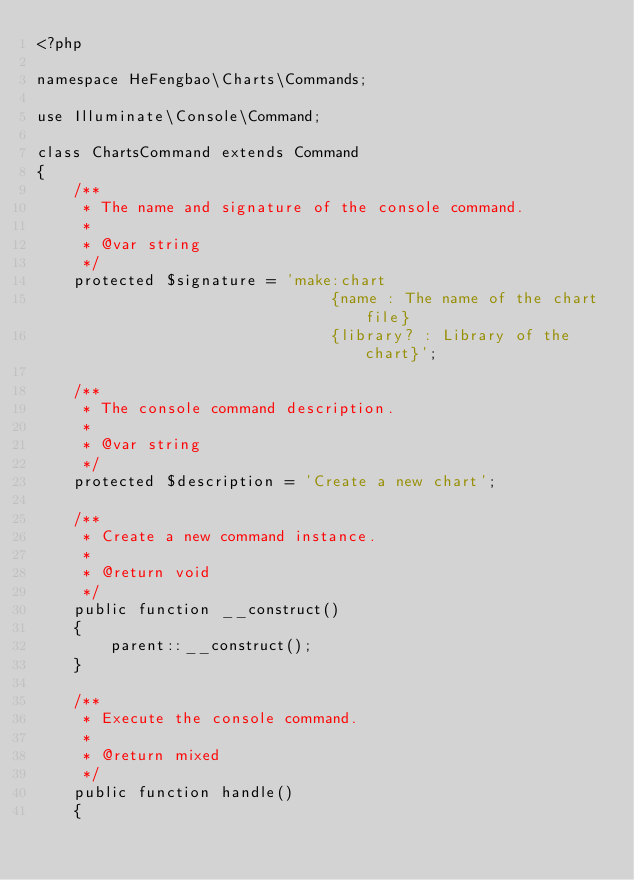Convert code to text. <code><loc_0><loc_0><loc_500><loc_500><_PHP_><?php

namespace HeFengbao\Charts\Commands;

use Illuminate\Console\Command;

class ChartsCommand extends Command
{
    /**
     * The name and signature of the console command.
     *
     * @var string
     */
    protected $signature = 'make:chart
                                {name : The name of the chart file}
                                {library? : Library of the chart}';

    /**
     * The console command description.
     *
     * @var string
     */
    protected $description = 'Create a new chart';

    /**
     * Create a new command instance.
     *
     * @return void
     */
    public function __construct()
    {
        parent::__construct();
    }

    /**
     * Execute the console command.
     *
     * @return mixed
     */
    public function handle()
    {</code> 